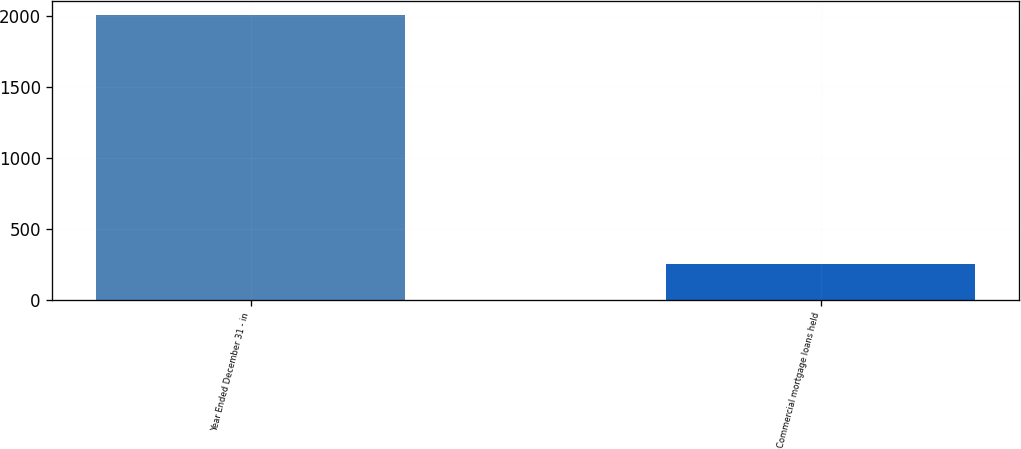Convert chart to OTSL. <chart><loc_0><loc_0><loc_500><loc_500><bar_chart><fcel>Year Ended December 31 - in<fcel>Commercial mortgage loans held<nl><fcel>2008<fcel>251<nl></chart> 